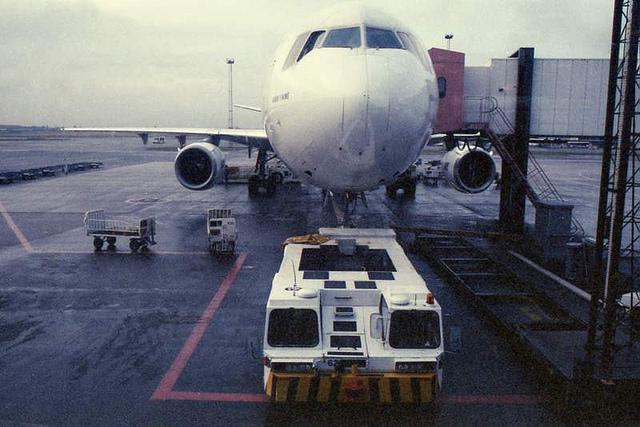The items on the left and right of the front of the biggest vehicle here are called what?
Make your selection from the four choices given to correctly answer the question.
Options: Jet engines, wheels, missiles, cannons. Jet engines. 